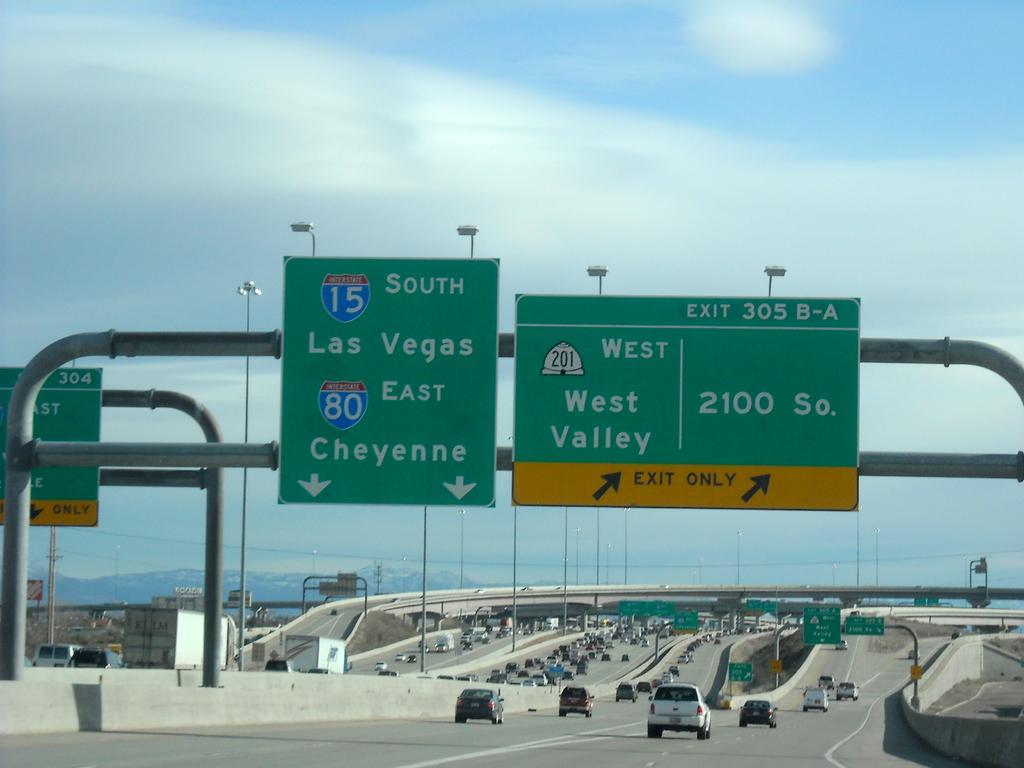What city is south?
Give a very brief answer. Las vegas. 